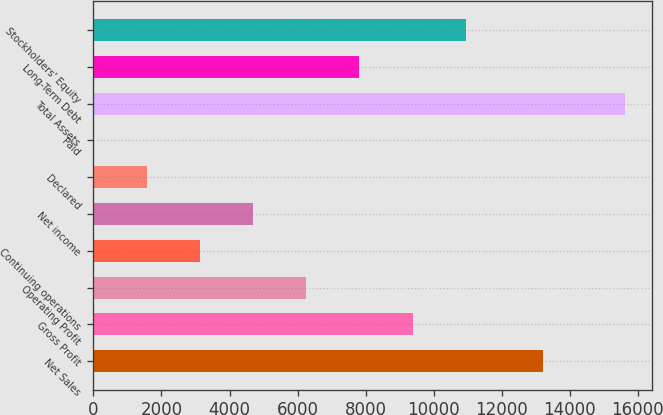Convert chart to OTSL. <chart><loc_0><loc_0><loc_500><loc_500><bar_chart><fcel>Net Sales<fcel>Gross Profit<fcel>Operating Profit<fcel>Continuing operations<fcel>Net income<fcel>Declared<fcel>Paid<fcel>Total Assets<fcel>Long-Term Debt<fcel>Stockholders' Equity<nl><fcel>13231.5<fcel>9384.22<fcel>6256.54<fcel>3128.86<fcel>4692.7<fcel>1565.02<fcel>1.18<fcel>15639.6<fcel>7820.38<fcel>10948.1<nl></chart> 